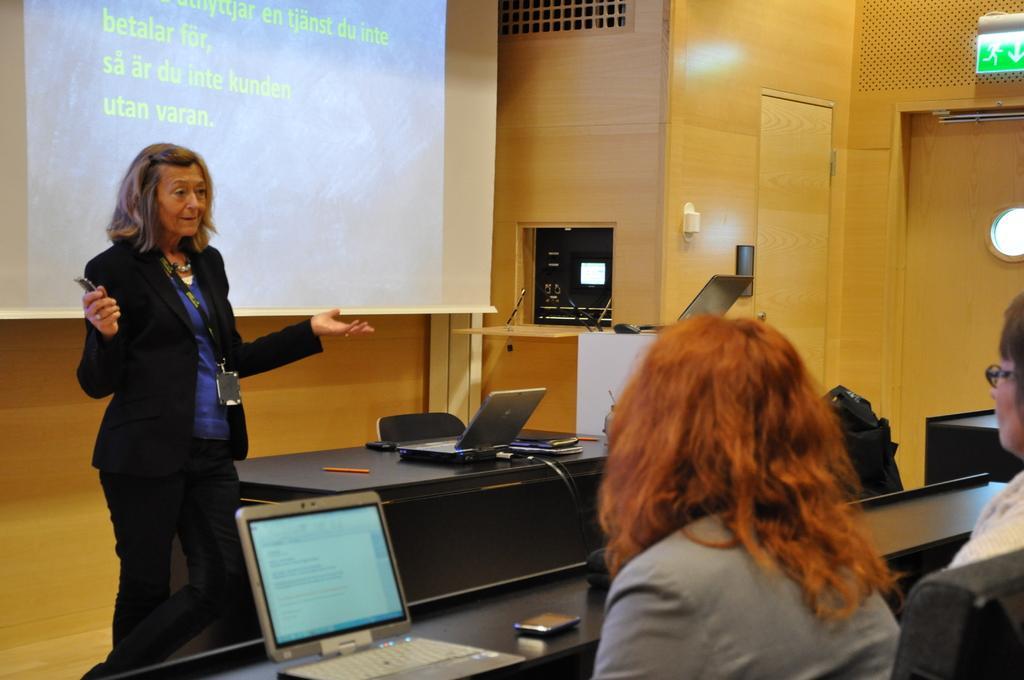How would you summarize this image in a sentence or two? In this picture we can see a woman in the black blazer. On the right side of the image, there is a laptop, cables and some objects on the table. On the right side of the table there are some items. Behind the woman, there is a projector screen. At the bottom right corner of the image, there are two persons and in front of the two persons there is another table. On the table there is a laptop and a mobile. At the top right corner of the image, there is a door and a sign board. 